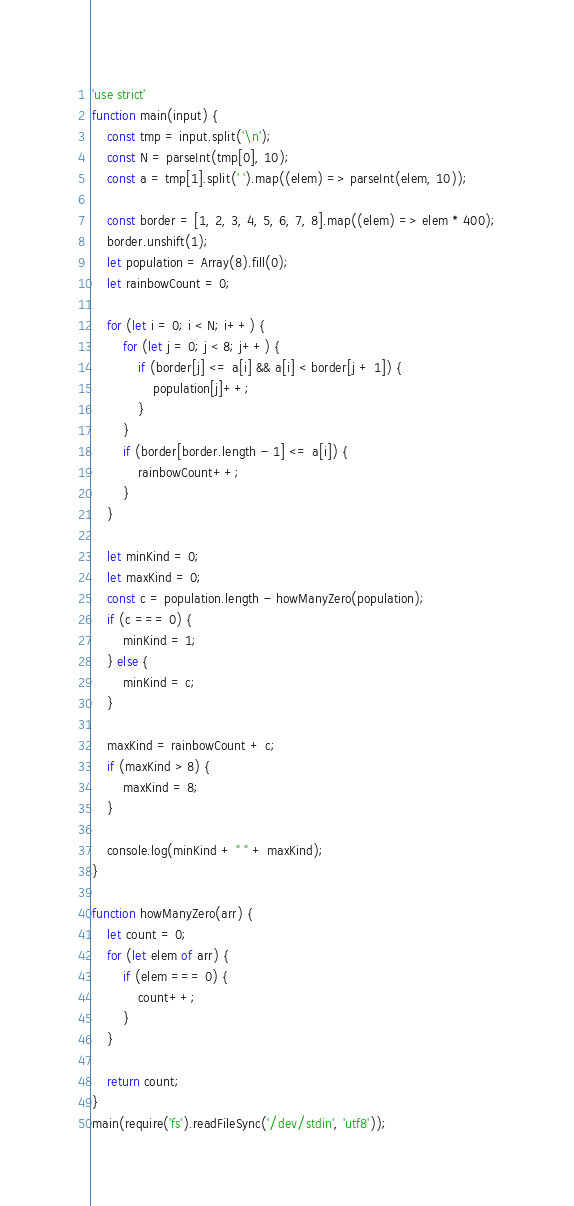Convert code to text. <code><loc_0><loc_0><loc_500><loc_500><_JavaScript_>'use strict'
function main(input) {
    const tmp = input.split('\n');
    const N = parseInt(tmp[0], 10);
    const a = tmp[1].split(' ').map((elem) => parseInt(elem, 10));

    const border = [1, 2, 3, 4, 5, 6, 7, 8].map((elem) => elem * 400);
    border.unshift(1);
    let population = Array(8).fill(0);
    let rainbowCount = 0;

    for (let i = 0; i < N; i++) {
        for (let j = 0; j < 8; j++) {
            if (border[j] <= a[i] && a[i] < border[j + 1]) {
                population[j]++;
            }
        }
        if (border[border.length - 1] <= a[i]) {
            rainbowCount++;
        }
    }

    let minKind = 0;
    let maxKind = 0;
    const c = population.length - howManyZero(population);
    if (c === 0) {
        minKind = 1;
    } else {
        minKind = c;
    }

    maxKind = rainbowCount + c;
    if (maxKind > 8) {
        maxKind = 8;
    }

    console.log(minKind + " " + maxKind);
}

function howManyZero(arr) {
    let count = 0;
    for (let elem of arr) {
        if (elem === 0) {
            count++;
        }
    }

    return count;
}
main(require('fs').readFileSync('/dev/stdin', 'utf8'));</code> 